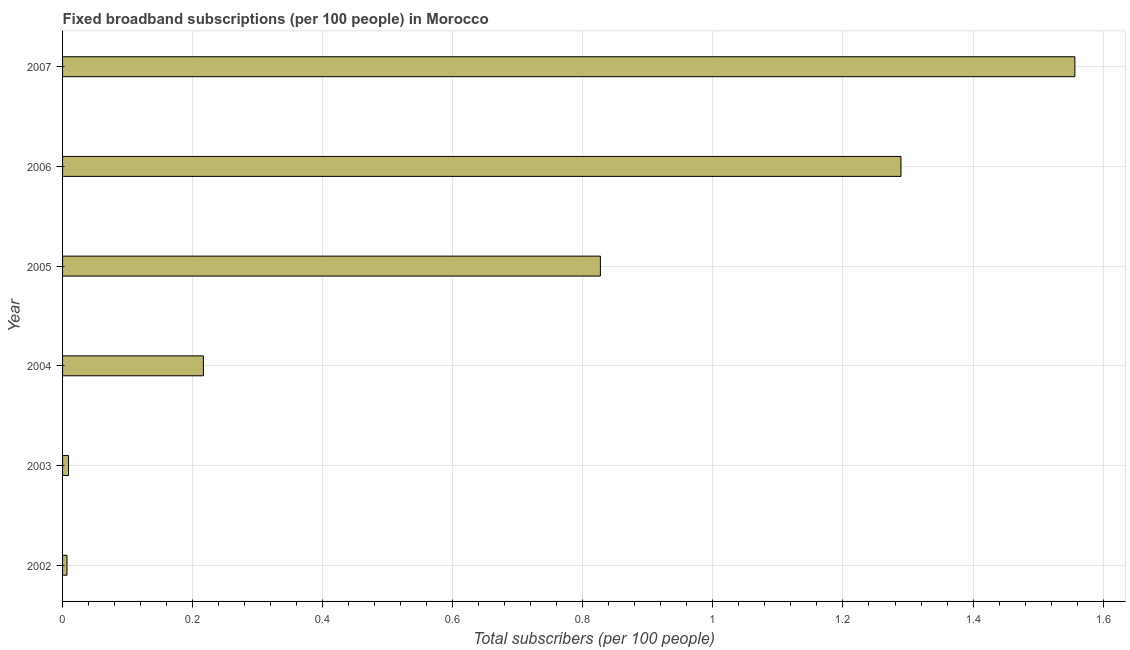Does the graph contain any zero values?
Your response must be concise. No. Does the graph contain grids?
Offer a very short reply. Yes. What is the title of the graph?
Keep it short and to the point. Fixed broadband subscriptions (per 100 people) in Morocco. What is the label or title of the X-axis?
Make the answer very short. Total subscribers (per 100 people). What is the total number of fixed broadband subscriptions in 2004?
Give a very brief answer. 0.22. Across all years, what is the maximum total number of fixed broadband subscriptions?
Make the answer very short. 1.56. Across all years, what is the minimum total number of fixed broadband subscriptions?
Ensure brevity in your answer.  0.01. What is the sum of the total number of fixed broadband subscriptions?
Offer a very short reply. 3.91. What is the difference between the total number of fixed broadband subscriptions in 2005 and 2007?
Your answer should be compact. -0.73. What is the average total number of fixed broadband subscriptions per year?
Keep it short and to the point. 0.65. What is the median total number of fixed broadband subscriptions?
Provide a succinct answer. 0.52. What is the ratio of the total number of fixed broadband subscriptions in 2002 to that in 2007?
Provide a succinct answer. 0. What is the difference between the highest and the second highest total number of fixed broadband subscriptions?
Ensure brevity in your answer.  0.27. Is the sum of the total number of fixed broadband subscriptions in 2003 and 2004 greater than the maximum total number of fixed broadband subscriptions across all years?
Provide a short and direct response. No. What is the difference between the highest and the lowest total number of fixed broadband subscriptions?
Keep it short and to the point. 1.55. How many bars are there?
Your response must be concise. 6. How many years are there in the graph?
Ensure brevity in your answer.  6. What is the Total subscribers (per 100 people) in 2002?
Provide a short and direct response. 0.01. What is the Total subscribers (per 100 people) in 2003?
Ensure brevity in your answer.  0.01. What is the Total subscribers (per 100 people) in 2004?
Your response must be concise. 0.22. What is the Total subscribers (per 100 people) of 2005?
Ensure brevity in your answer.  0.83. What is the Total subscribers (per 100 people) of 2006?
Ensure brevity in your answer.  1.29. What is the Total subscribers (per 100 people) of 2007?
Your response must be concise. 1.56. What is the difference between the Total subscribers (per 100 people) in 2002 and 2003?
Provide a succinct answer. -0. What is the difference between the Total subscribers (per 100 people) in 2002 and 2004?
Give a very brief answer. -0.21. What is the difference between the Total subscribers (per 100 people) in 2002 and 2005?
Your response must be concise. -0.82. What is the difference between the Total subscribers (per 100 people) in 2002 and 2006?
Provide a short and direct response. -1.28. What is the difference between the Total subscribers (per 100 people) in 2002 and 2007?
Keep it short and to the point. -1.55. What is the difference between the Total subscribers (per 100 people) in 2003 and 2004?
Keep it short and to the point. -0.21. What is the difference between the Total subscribers (per 100 people) in 2003 and 2005?
Provide a short and direct response. -0.82. What is the difference between the Total subscribers (per 100 people) in 2003 and 2006?
Your answer should be compact. -1.28. What is the difference between the Total subscribers (per 100 people) in 2003 and 2007?
Your answer should be compact. -1.55. What is the difference between the Total subscribers (per 100 people) in 2004 and 2005?
Make the answer very short. -0.61. What is the difference between the Total subscribers (per 100 people) in 2004 and 2006?
Offer a terse response. -1.07. What is the difference between the Total subscribers (per 100 people) in 2004 and 2007?
Your answer should be very brief. -1.34. What is the difference between the Total subscribers (per 100 people) in 2005 and 2006?
Your response must be concise. -0.46. What is the difference between the Total subscribers (per 100 people) in 2005 and 2007?
Your answer should be very brief. -0.73. What is the difference between the Total subscribers (per 100 people) in 2006 and 2007?
Your response must be concise. -0.27. What is the ratio of the Total subscribers (per 100 people) in 2002 to that in 2003?
Provide a succinct answer. 0.74. What is the ratio of the Total subscribers (per 100 people) in 2002 to that in 2004?
Give a very brief answer. 0.03. What is the ratio of the Total subscribers (per 100 people) in 2002 to that in 2005?
Your answer should be compact. 0.01. What is the ratio of the Total subscribers (per 100 people) in 2002 to that in 2006?
Give a very brief answer. 0.01. What is the ratio of the Total subscribers (per 100 people) in 2002 to that in 2007?
Offer a terse response. 0. What is the ratio of the Total subscribers (per 100 people) in 2003 to that in 2004?
Your response must be concise. 0.04. What is the ratio of the Total subscribers (per 100 people) in 2003 to that in 2005?
Keep it short and to the point. 0.01. What is the ratio of the Total subscribers (per 100 people) in 2003 to that in 2006?
Make the answer very short. 0.01. What is the ratio of the Total subscribers (per 100 people) in 2003 to that in 2007?
Offer a very short reply. 0.01. What is the ratio of the Total subscribers (per 100 people) in 2004 to that in 2005?
Your answer should be compact. 0.26. What is the ratio of the Total subscribers (per 100 people) in 2004 to that in 2006?
Provide a succinct answer. 0.17. What is the ratio of the Total subscribers (per 100 people) in 2004 to that in 2007?
Give a very brief answer. 0.14. What is the ratio of the Total subscribers (per 100 people) in 2005 to that in 2006?
Make the answer very short. 0.64. What is the ratio of the Total subscribers (per 100 people) in 2005 to that in 2007?
Offer a very short reply. 0.53. What is the ratio of the Total subscribers (per 100 people) in 2006 to that in 2007?
Provide a succinct answer. 0.83. 